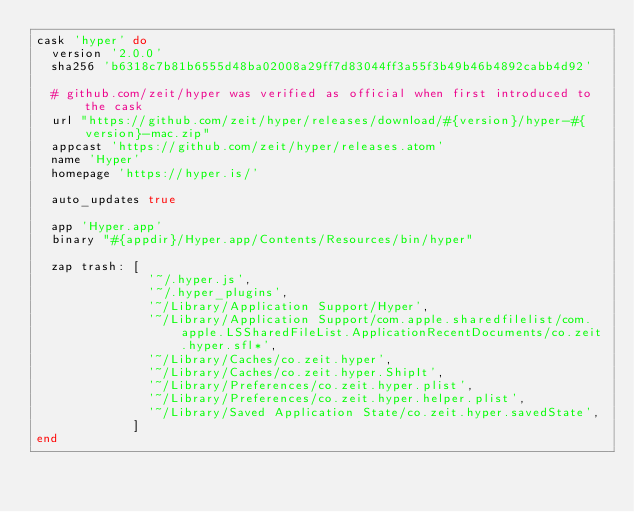Convert code to text. <code><loc_0><loc_0><loc_500><loc_500><_Ruby_>cask 'hyper' do
  version '2.0.0'
  sha256 'b6318c7b81b6555d48ba02008a29ff7d83044ff3a55f3b49b46b4892cabb4d92'

  # github.com/zeit/hyper was verified as official when first introduced to the cask
  url "https://github.com/zeit/hyper/releases/download/#{version}/hyper-#{version}-mac.zip"
  appcast 'https://github.com/zeit/hyper/releases.atom'
  name 'Hyper'
  homepage 'https://hyper.is/'

  auto_updates true

  app 'Hyper.app'
  binary "#{appdir}/Hyper.app/Contents/Resources/bin/hyper"

  zap trash: [
               '~/.hyper.js',
               '~/.hyper_plugins',
               '~/Library/Application Support/Hyper',
               '~/Library/Application Support/com.apple.sharedfilelist/com.apple.LSSharedFileList.ApplicationRecentDocuments/co.zeit.hyper.sfl*',
               '~/Library/Caches/co.zeit.hyper',
               '~/Library/Caches/co.zeit.hyper.ShipIt',
               '~/Library/Preferences/co.zeit.hyper.plist',
               '~/Library/Preferences/co.zeit.hyper.helper.plist',
               '~/Library/Saved Application State/co.zeit.hyper.savedState',
             ]
end
</code> 